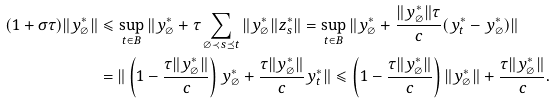<formula> <loc_0><loc_0><loc_500><loc_500>( 1 + \sigma \tau ) \| y ^ { * } _ { \varnothing } \| & \leqslant \sup _ { t \in B } \| y ^ { * } _ { \varnothing } + \tau \sum _ { \varnothing \prec s \preceq t } \| y ^ { * } _ { \varnothing } \| z ^ { * } _ { s } \| = \sup _ { t \in B } \| y ^ { * } _ { \varnothing } + \frac { \| y ^ { * } _ { \varnothing } \| \tau } { c } ( y ^ { * } _ { t } - y ^ { * } _ { \varnothing } ) \| \\ & = \| \left ( 1 - \frac { \tau \| y ^ { * } _ { \varnothing } \| } { c } \right ) y ^ { * } _ { \varnothing } + \frac { \tau \| y ^ { * } _ { \varnothing } \| } { c } y ^ { * } _ { t } \| \leqslant \left ( 1 - \frac { \tau \| y ^ { * } _ { \varnothing } \| } { c } \right ) \| y ^ { * } _ { \varnothing } \| + \frac { \tau \| y ^ { * } _ { \varnothing } \| } { c } .</formula> 